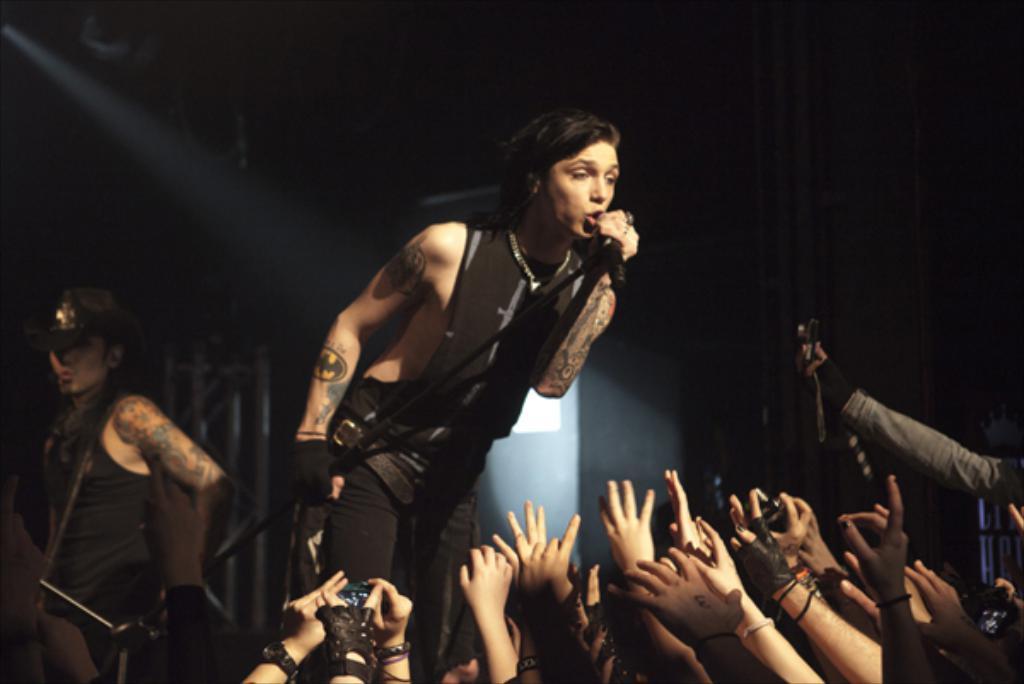In one or two sentences, can you explain what this image depicts? In this picture we can see a woman who is singing on the mike. Here we can see some persons. 